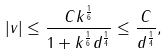<formula> <loc_0><loc_0><loc_500><loc_500>| v | \leq \frac { C k ^ { \frac { 1 } { 6 } } } { 1 + k ^ { \frac { 1 } { 6 } } d ^ { \frac { 1 } { 4 } } } \leq \frac { C } { d ^ { \frac { 1 } { 4 } } } ,</formula> 